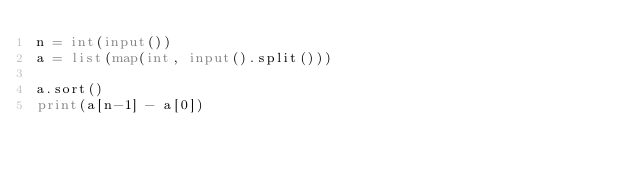Convert code to text. <code><loc_0><loc_0><loc_500><loc_500><_Python_>n = int(input())
a = list(map(int, input().split()))

a.sort()
print(a[n-1] - a[0])</code> 